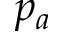Convert formula to latex. <formula><loc_0><loc_0><loc_500><loc_500>p _ { a }</formula> 